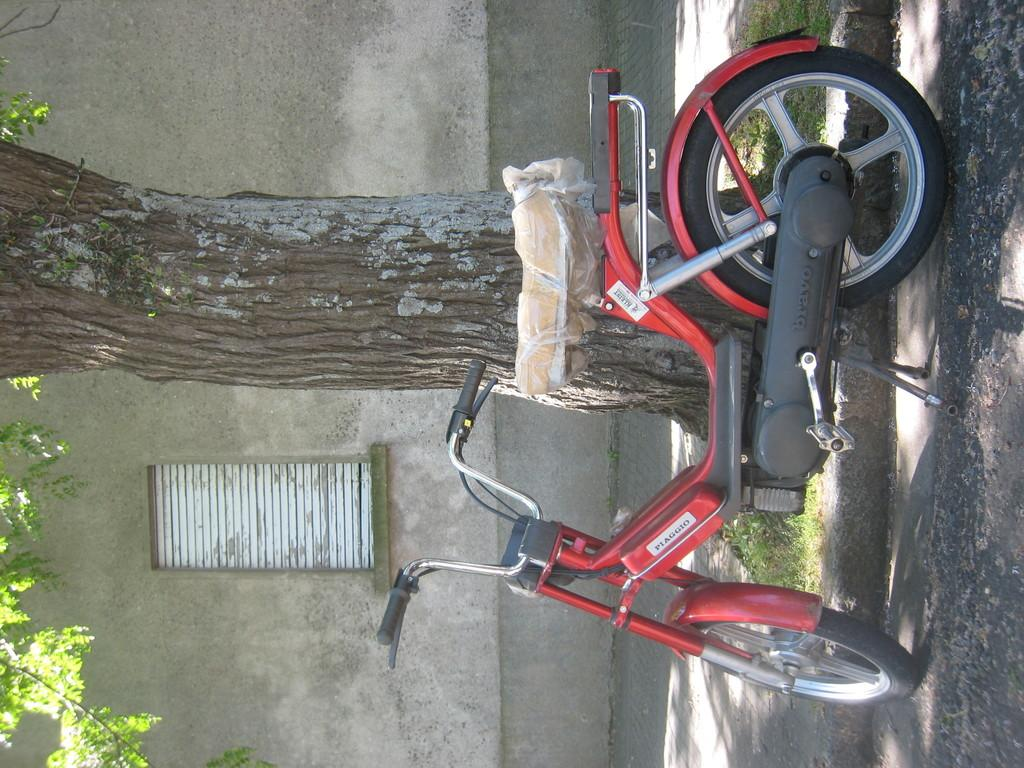What is the main subject of the image? The main subject of the image is a motorcycle. Can you describe the color of the motorcycle? The motorcycle is red and black in color. What can be seen in the foreground of the image? There is a path and grass visible in the foreground of the image. What is present in the background of the image? There is a tree and a wall in the background of the image. What type of credit card is being used to purchase the motorcycle in the image? There is no credit card or purchase being depicted in the image; it simply shows a motorcycle. What drink is being offered to the person riding the motorcycle in the image? There is no person or drink present in the image; it only features a motorcycle. 